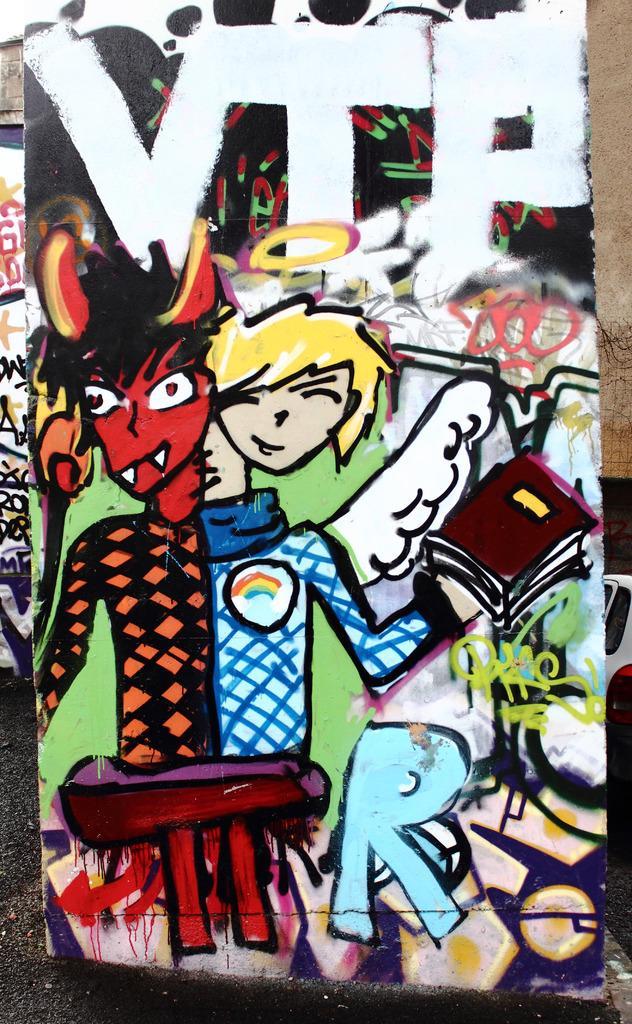In one or two sentences, can you explain what this image depicts? In this picture I can see there is a painting and there is a boy who has horns and wings holding a book. There is something written here. 